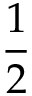Convert formula to latex. <formula><loc_0><loc_0><loc_500><loc_500>\frac { 1 } { 2 }</formula> 